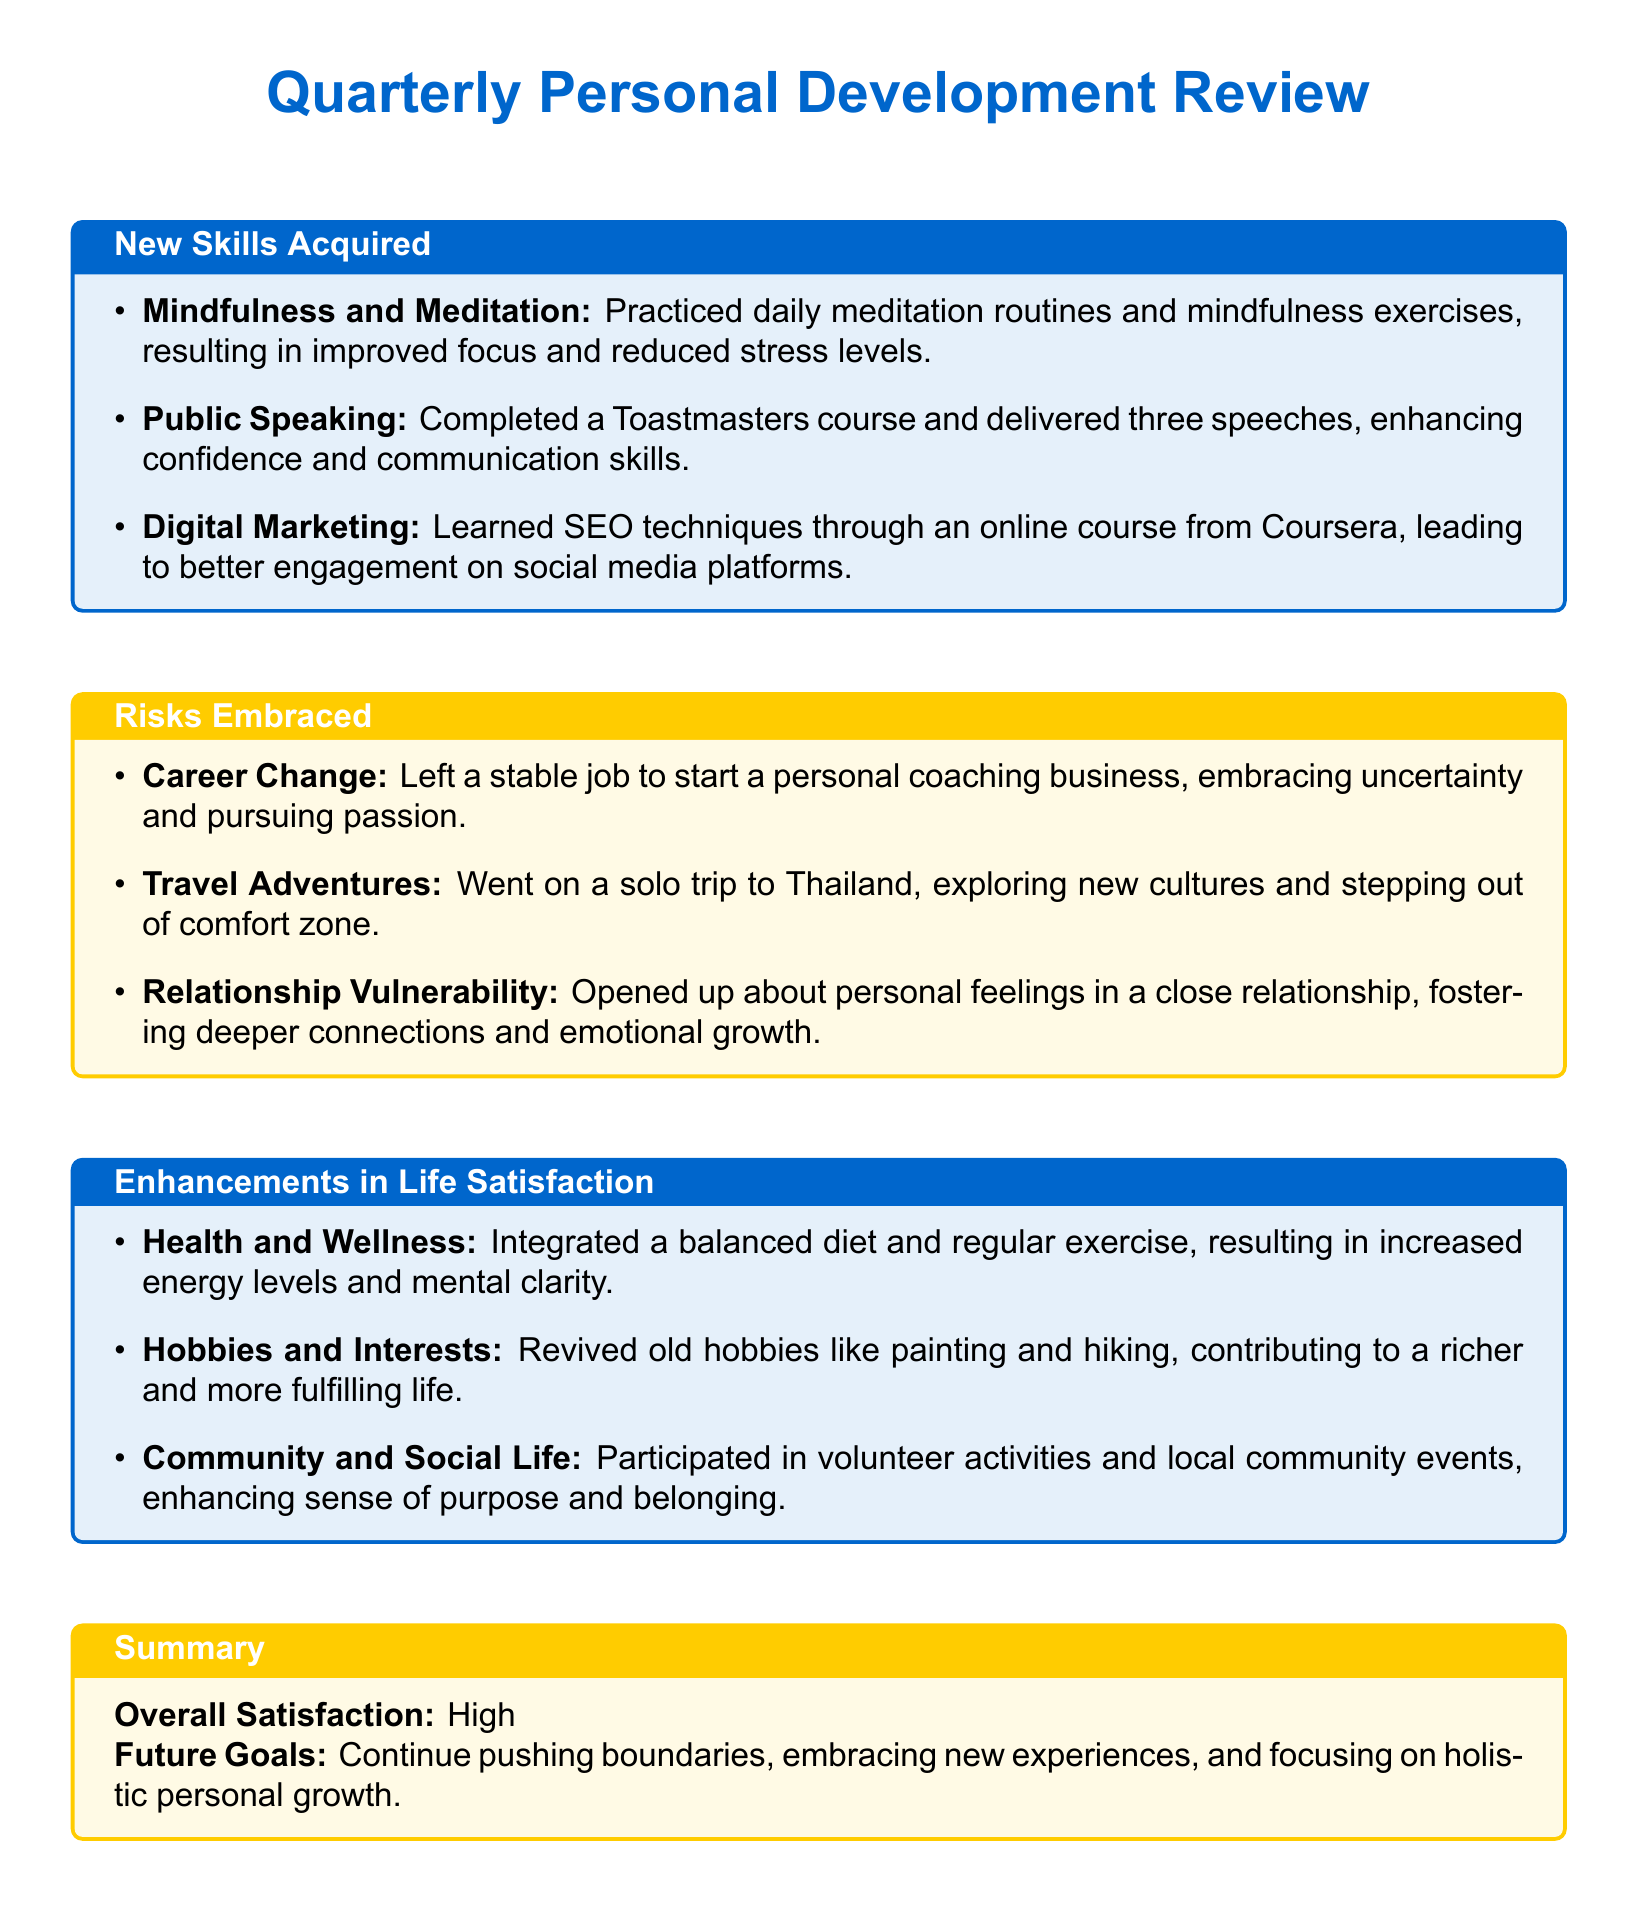what new skill was learned from an online course? The document lists learning SEO techniques as a new skill acquired through an online course from Coursera.
Answer: SEO techniques what personal risk was embraced related to employment? The document mentions leaving a stable job to start a personal coaching business as a career change risk.
Answer: Career Change how many speeches were delivered after completing the Toastmasters course? The document states that three speeches were delivered after completing the Toastmasters course.
Answer: three speeches what type of community activity was participated in? The document indicates participation in volunteer activities and local community events as part of social engagement.
Answer: volunteer activities what is the overall satisfaction level stated in the summary? The document mentions the overall satisfaction level as "High".
Answer: High what new hobby was revived this quarter? The document mentions painting and hiking as previously enjoyed hobbies that were revived.
Answer: painting how did the individual enhance their health and wellness? The document states that integrating a balanced diet and regular exercise enhanced energy levels and mental clarity.
Answer: balanced diet and regular exercise what country was visited on a solo trip? The document specifies that Thailand was the country visited on the solo trip.
Answer: Thailand what is the focus for future goals mentioned in the scorecard? The document states that the focus for future goals is on pushing boundaries and embracing new experiences.
Answer: pushing boundaries 